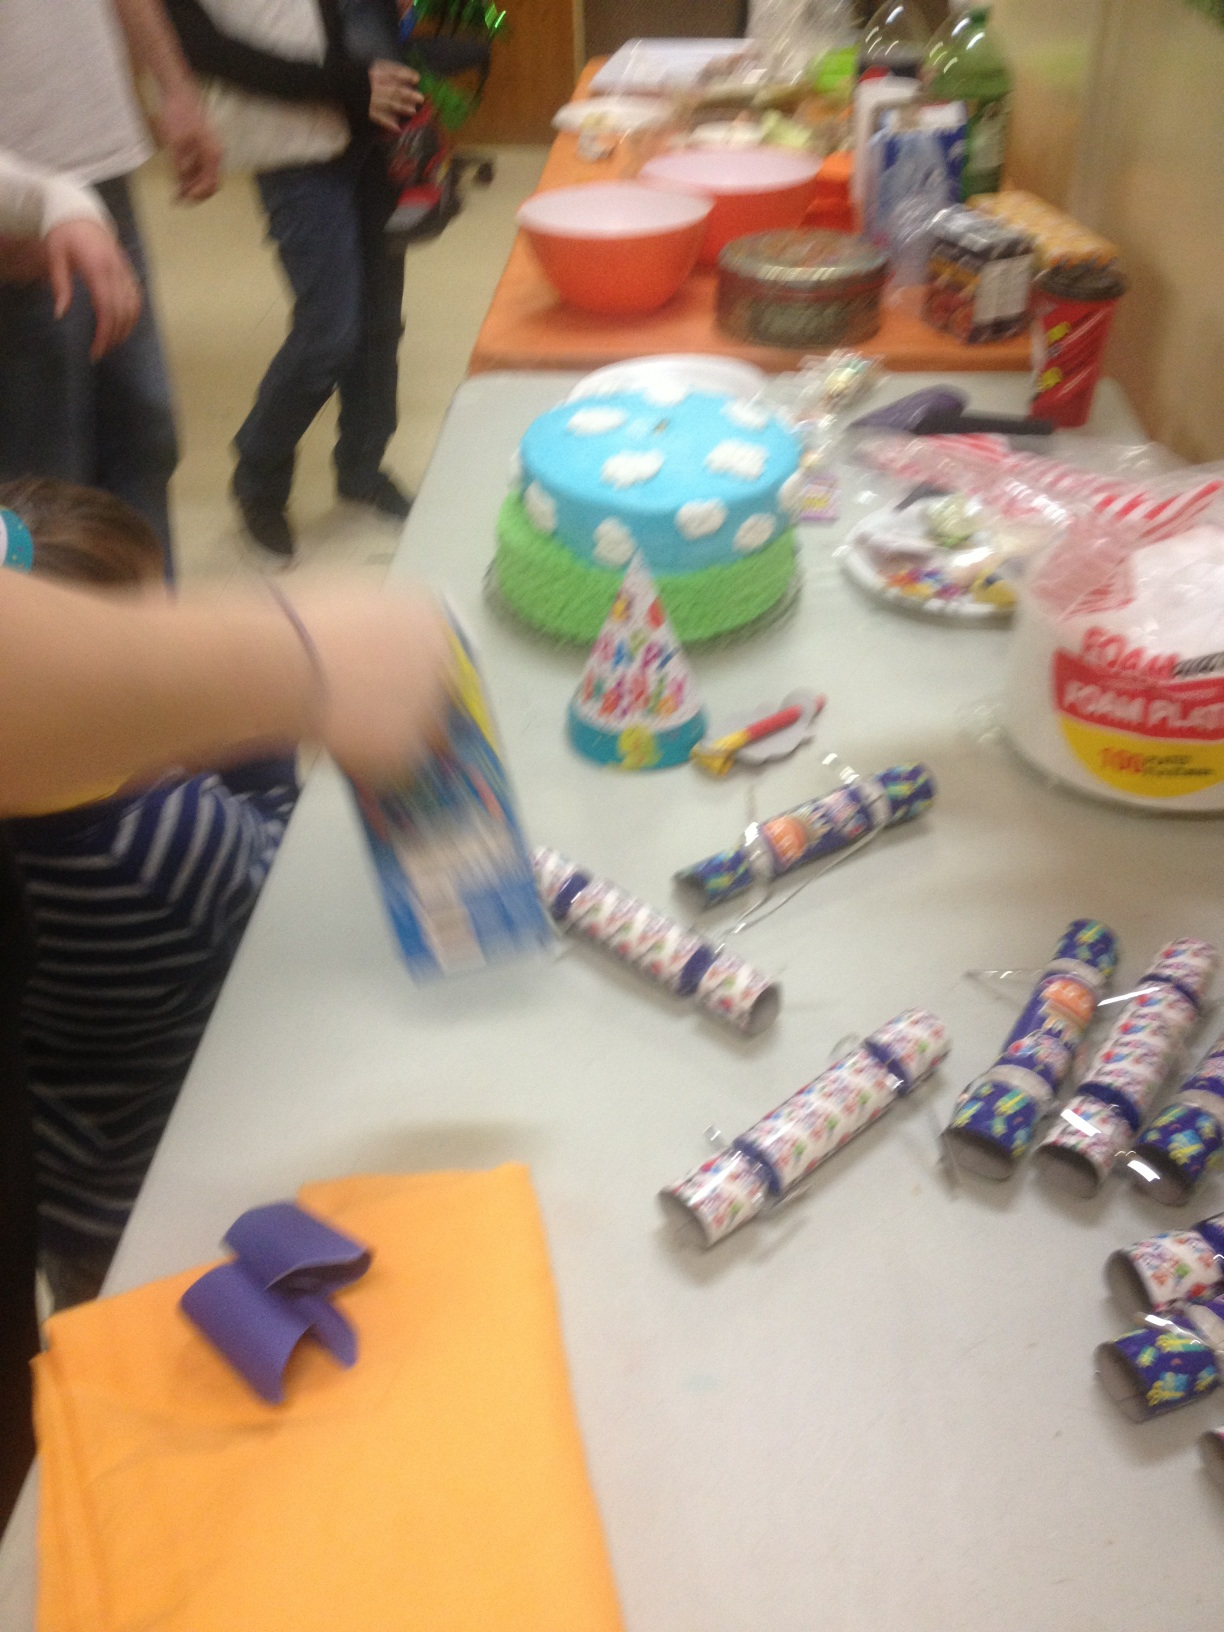What is it? The image shows a children's party setting with a cake decorated in blue and green, resembling a cloud or sky theme, party hats, and multiple party favors on the table. The scene is colorful and festive, typical of a birthday celebration. 